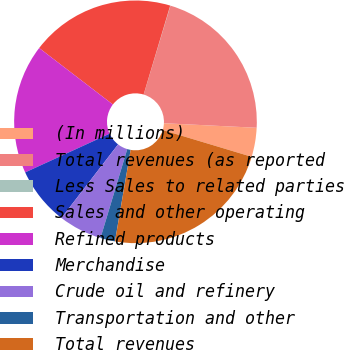Convert chart. <chart><loc_0><loc_0><loc_500><loc_500><pie_chart><fcel>(In millions)<fcel>Total revenues (as reported<fcel>Less Sales to related parties<fcel>Sales and other operating<fcel>Refined products<fcel>Merchandise<fcel>Crude oil and refinery<fcel>Transportation and other<fcel>Total revenues<nl><fcel>3.87%<fcel>21.13%<fcel>0.03%<fcel>19.21%<fcel>17.25%<fcel>7.71%<fcel>5.79%<fcel>1.95%<fcel>23.05%<nl></chart> 